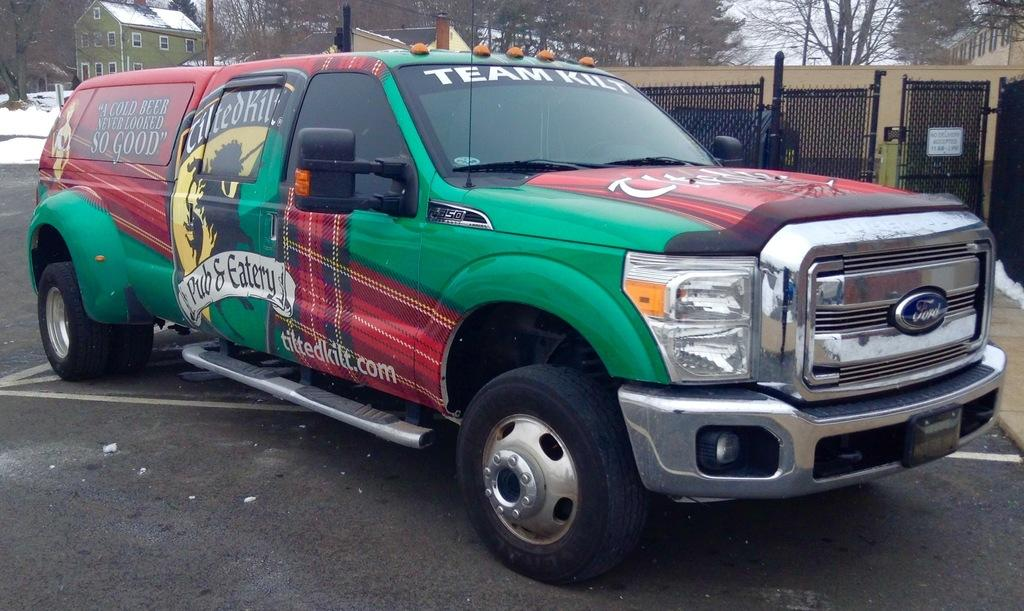What is the main subject of the image? There is a vehicle in the image. Where is the vehicle located? The vehicle is on the road. What colors can be seen on the vehicle? The vehicle has green, red, and black colors. What can be seen in the background of the image? There are trees and a house in the background of the image. What type of heat-resistant apparatus is being used by the nation in the image? There is no heat-resistant apparatus or reference to a nation in the image; it features a vehicle on the road with green, red, and black colors, and trees and a house in the background. 